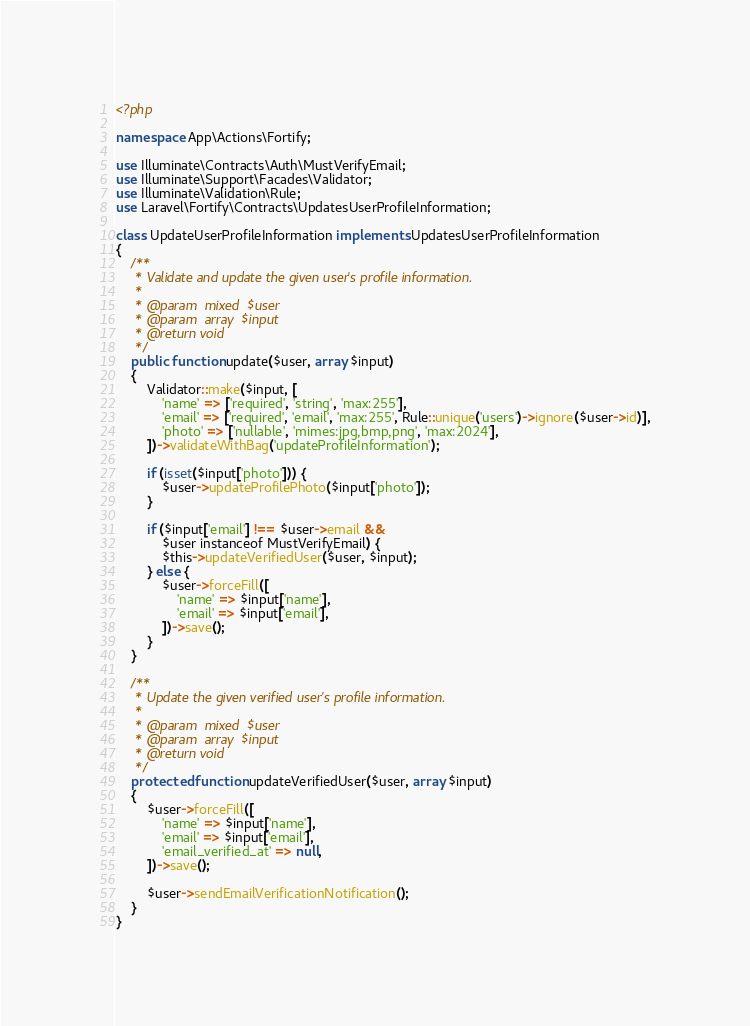<code> <loc_0><loc_0><loc_500><loc_500><_PHP_><?php

namespace App\Actions\Fortify;

use Illuminate\Contracts\Auth\MustVerifyEmail;
use Illuminate\Support\Facades\Validator;
use Illuminate\Validation\Rule;
use Laravel\Fortify\Contracts\UpdatesUserProfileInformation;

class UpdateUserProfileInformation implements UpdatesUserProfileInformation
{
    /**
     * Validate and update the given user's profile information.
     *
     * @param  mixed  $user
     * @param  array  $input
     * @return void
     */
    public function update($user, array $input)
    {
        Validator::make($input, [
            'name' => ['required', 'string', 'max:255'],
            'email' => ['required', 'email', 'max:255', Rule::unique('users')->ignore($user->id)],
            'photo' => ['nullable', 'mimes:jpg,bmp,png', 'max:2024'],
        ])->validateWithBag('updateProfileInformation');

        if (isset($input['photo'])) {
            $user->updateProfilePhoto($input['photo']);
        }

        if ($input['email'] !== $user->email &&
            $user instanceof MustVerifyEmail) {
            $this->updateVerifiedUser($user, $input);
        } else {
            $user->forceFill([
                'name' => $input['name'],
                'email' => $input['email'],
            ])->save();
        }
    }

    /**
     * Update the given verified user's profile information.
     *
     * @param  mixed  $user
     * @param  array  $input
     * @return void
     */
    protected function updateVerifiedUser($user, array $input)
    {
        $user->forceFill([
            'name' => $input['name'],
            'email' => $input['email'],
            'email_verified_at' => null,
        ])->save();

        $user->sendEmailVerificationNotification();
    }
}
</code> 